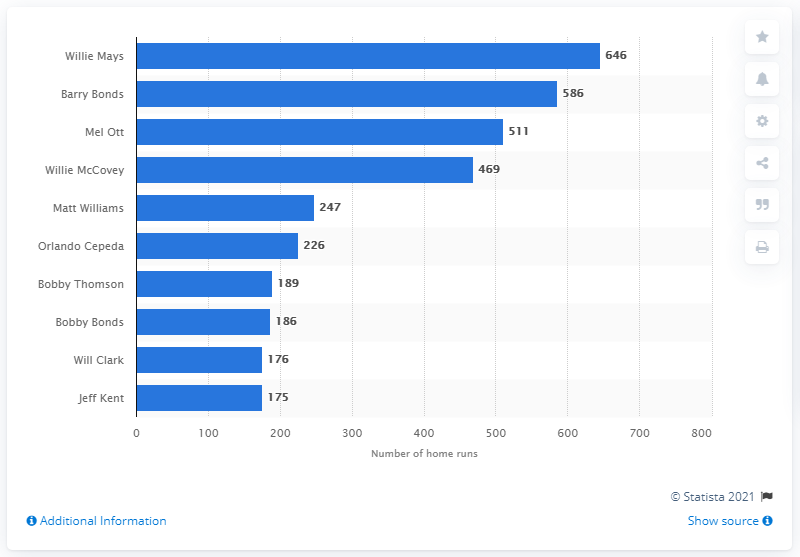Mention a couple of crucial points in this snapshot. Willie Mays, a renowned American baseball player, has hit a total of 646 home runs throughout his illustrious career. Willie Mays is the San Francisco Giants franchise history holder of the most home runs hit. 